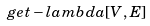<formula> <loc_0><loc_0><loc_500><loc_500>g e t - l a m b d a [ V , E ]</formula> 